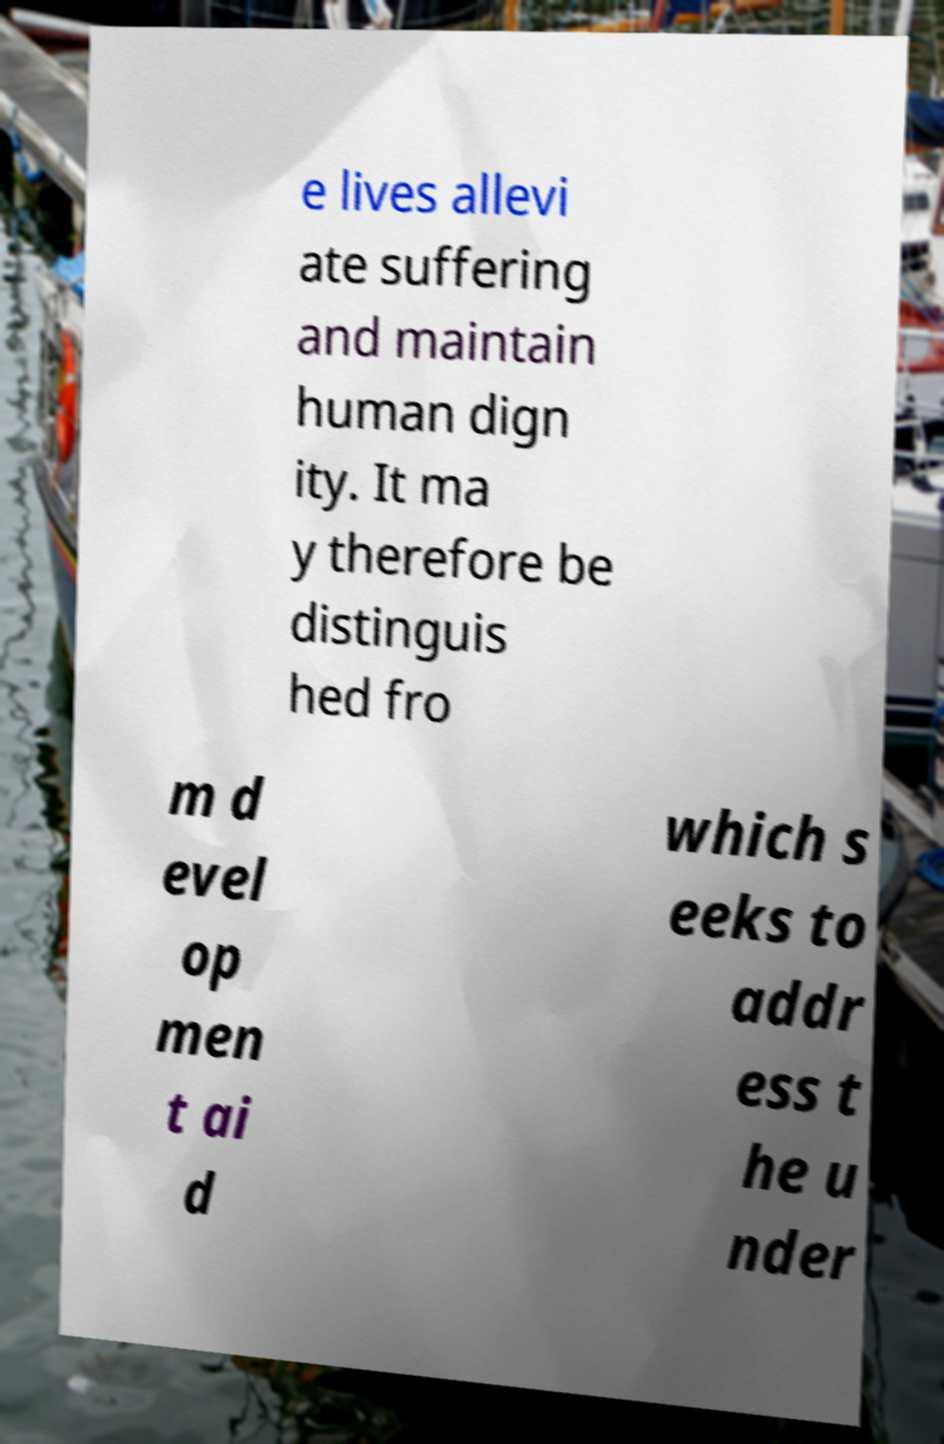I need the written content from this picture converted into text. Can you do that? e lives allevi ate suffering and maintain human dign ity. It ma y therefore be distinguis hed fro m d evel op men t ai d which s eeks to addr ess t he u nder 